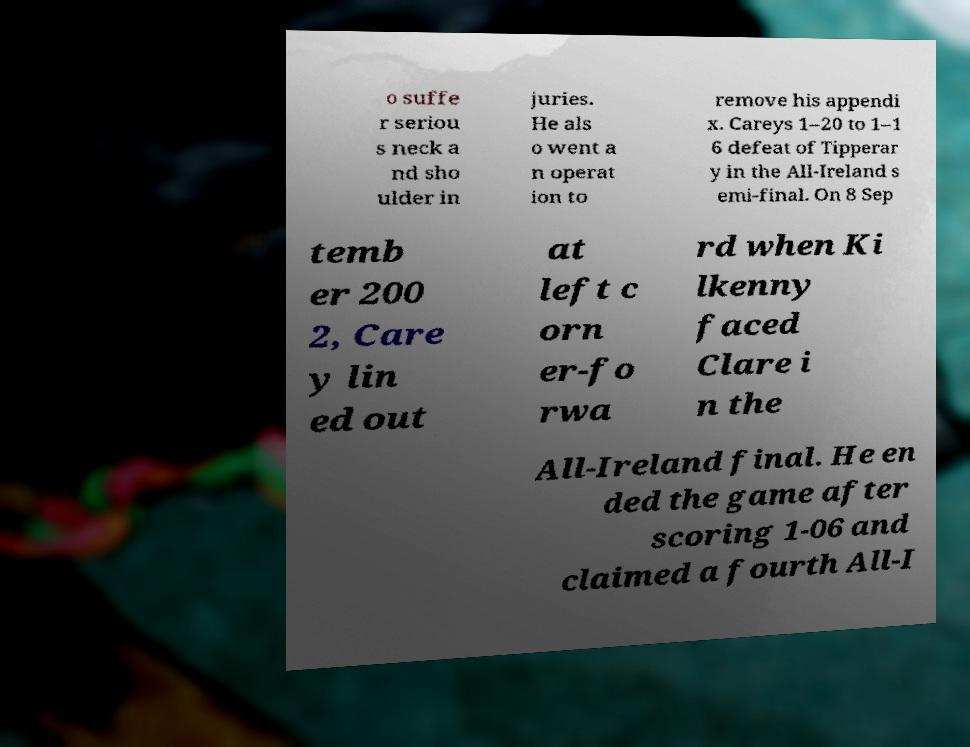Please read and relay the text visible in this image. What does it say? o suffe r seriou s neck a nd sho ulder in juries. He als o went a n operat ion to remove his appendi x. Careys 1–20 to 1–1 6 defeat of Tipperar y in the All-Ireland s emi-final. On 8 Sep temb er 200 2, Care y lin ed out at left c orn er-fo rwa rd when Ki lkenny faced Clare i n the All-Ireland final. He en ded the game after scoring 1-06 and claimed a fourth All-I 